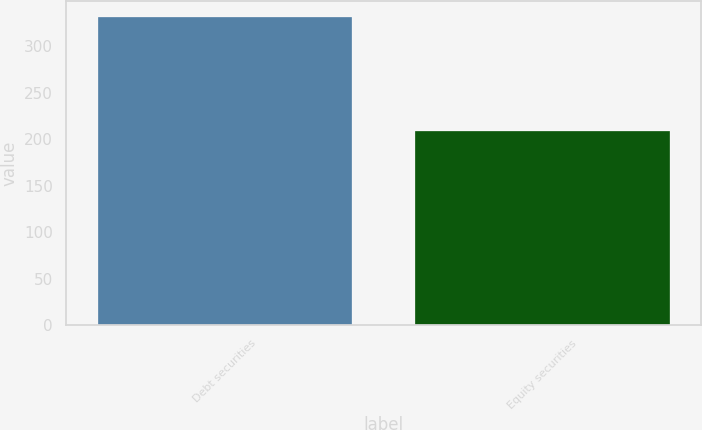Convert chart to OTSL. <chart><loc_0><loc_0><loc_500><loc_500><bar_chart><fcel>Debt securities<fcel>Equity securities<nl><fcel>332<fcel>209<nl></chart> 